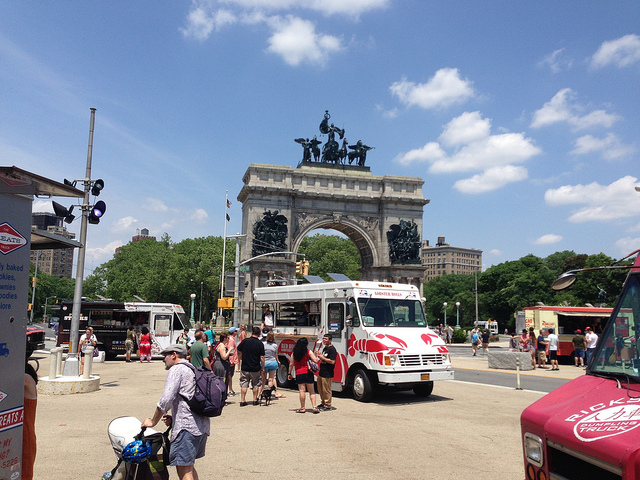Let's create an extremely imaginative storyline involving the monument, perhaps involving mythical creatures or magical events. In a world where mythical creatures roam hidden among us, this majestic monument serves as a portal to a parallel realm. By day, it stands as a grand historical arch, but when the moonlight hits its sculptures, they come to life, revealing their true forms as guardians of an ancient secret. The heroes of our story, a group of modern-day explorers, discover that the monument is the key to unleashing a forgotten magic that once balanced the natural and supernatural worlds. As they navigate through clues and ancient myths, they uncover that these mythical guardians are the last line of defense against a pending cataclysm that could merge the realms forever, altering the fabric of reality. Imagine you are a journalist reporting live from this location. Provide a short, engaging news report. Good afternoon, this is [Your Name] reporting live from one of the city's most iconic landmarks. The vibrant scene here at the monument is nothing short of spectacular, with crowds of tourists and locals alike soaking in the sunny weather and the delicious offerings from the array of food trucks. This monument, a testament to our rich history, stands proudly in the backdrop as families, friends, and individuals gather to create memories. From here, you get a true sense of the community spirit and the city's ongoing blend of history and modernity. Stay tuned as we continue to explore more of what makes this place a beloved spot in our urban landscape. 